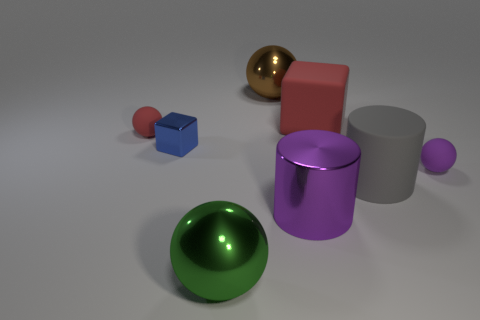The big rubber cube has what color?
Offer a very short reply. Red. Does the large gray thing have the same material as the purple thing that is right of the purple metal cylinder?
Your answer should be compact. Yes. What is the shape of the tiny object that is the same material as the purple cylinder?
Give a very brief answer. Cube. What is the color of the shiny cylinder that is the same size as the matte cube?
Offer a very short reply. Purple. Does the purple metal cylinder that is behind the green metallic object have the same size as the large brown sphere?
Provide a succinct answer. Yes. Does the small block have the same color as the metal cylinder?
Your response must be concise. No. How many small things are there?
Offer a very short reply. 3. What number of cylinders are big brown shiny things or tiny rubber objects?
Offer a very short reply. 0. How many tiny rubber things are on the right side of the red matte thing to the left of the big red cube?
Offer a very short reply. 1. Do the small purple sphere and the big brown sphere have the same material?
Your answer should be compact. No. 